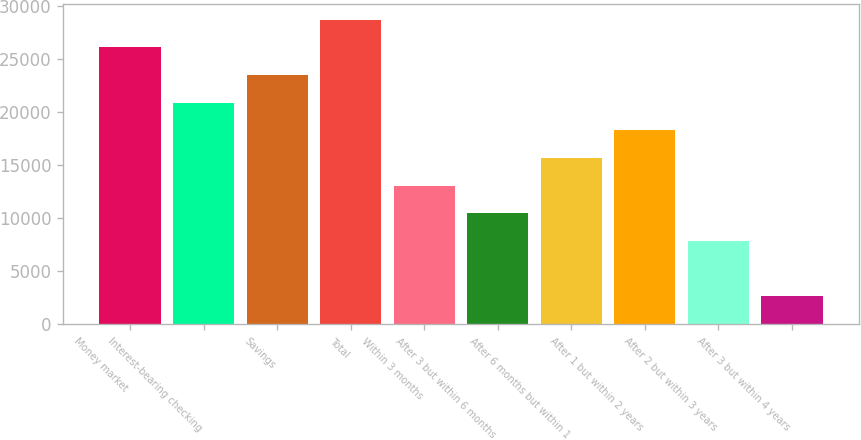Convert chart. <chart><loc_0><loc_0><loc_500><loc_500><bar_chart><fcel>Money market<fcel>Interest-bearing checking<fcel>Savings<fcel>Total<fcel>Within 3 months<fcel>After 3 but within 6 months<fcel>After 6 months but within 1<fcel>After 1 but within 2 years<fcel>After 2 but within 3 years<fcel>After 3 but within 4 years<nl><fcel>26138.2<fcel>20911.3<fcel>23524.7<fcel>28751.7<fcel>13070.9<fcel>10457.4<fcel>15684.4<fcel>18297.8<fcel>7843.98<fcel>2617.06<nl></chart> 